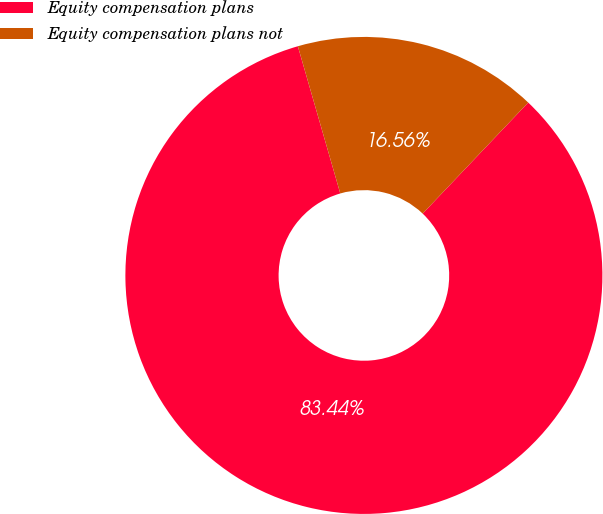<chart> <loc_0><loc_0><loc_500><loc_500><pie_chart><fcel>Equity compensation plans<fcel>Equity compensation plans not<nl><fcel>83.44%<fcel>16.56%<nl></chart> 